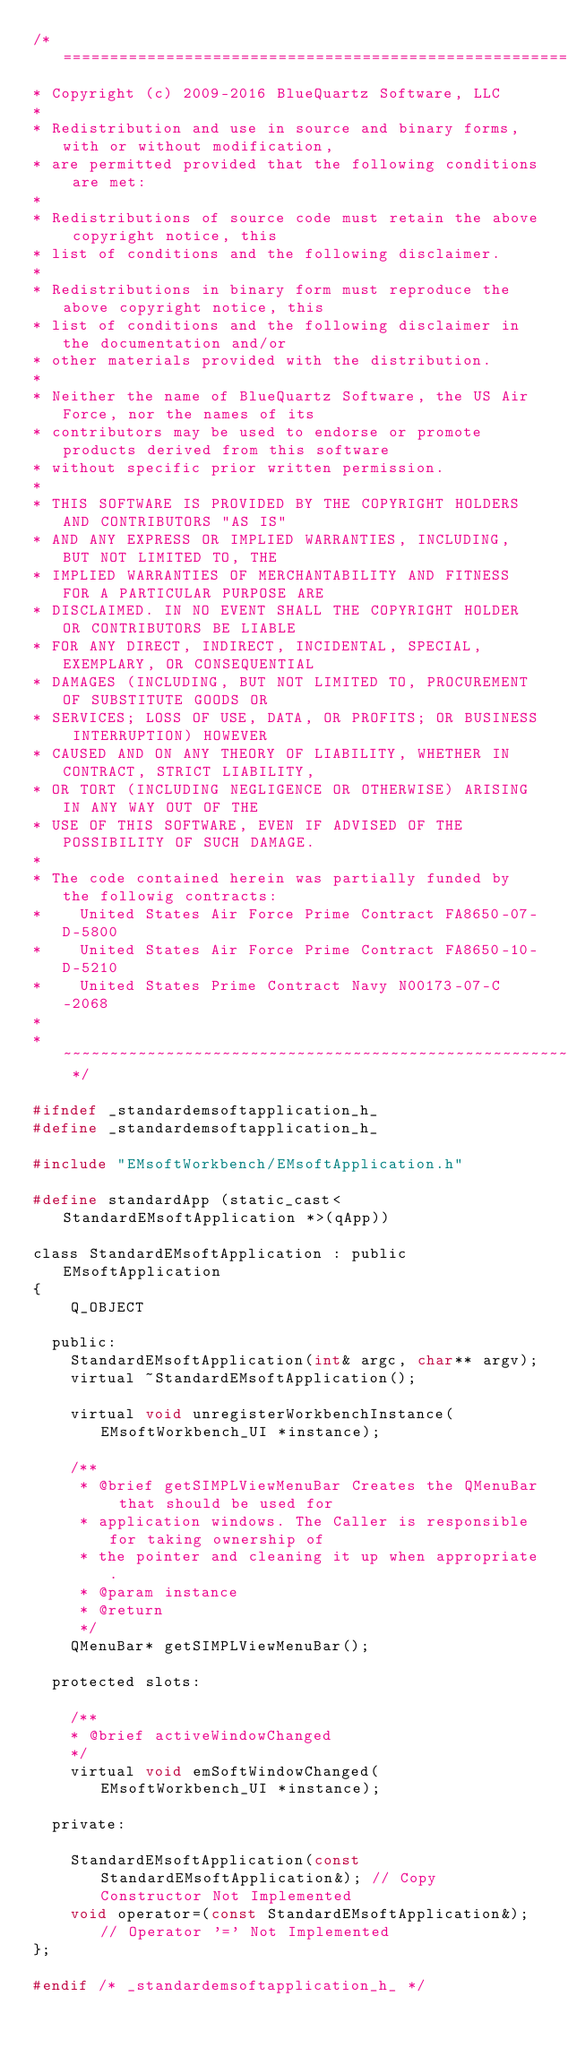Convert code to text. <code><loc_0><loc_0><loc_500><loc_500><_C_>/* ============================================================================
* Copyright (c) 2009-2016 BlueQuartz Software, LLC
*
* Redistribution and use in source and binary forms, with or without modification,
* are permitted provided that the following conditions are met:
*
* Redistributions of source code must retain the above copyright notice, this
* list of conditions and the following disclaimer.
*
* Redistributions in binary form must reproduce the above copyright notice, this
* list of conditions and the following disclaimer in the documentation and/or
* other materials provided with the distribution.
*
* Neither the name of BlueQuartz Software, the US Air Force, nor the names of its
* contributors may be used to endorse or promote products derived from this software
* without specific prior written permission.
*
* THIS SOFTWARE IS PROVIDED BY THE COPYRIGHT HOLDERS AND CONTRIBUTORS "AS IS"
* AND ANY EXPRESS OR IMPLIED WARRANTIES, INCLUDING, BUT NOT LIMITED TO, THE
* IMPLIED WARRANTIES OF MERCHANTABILITY AND FITNESS FOR A PARTICULAR PURPOSE ARE
* DISCLAIMED. IN NO EVENT SHALL THE COPYRIGHT HOLDER OR CONTRIBUTORS BE LIABLE
* FOR ANY DIRECT, INDIRECT, INCIDENTAL, SPECIAL, EXEMPLARY, OR CONSEQUENTIAL
* DAMAGES (INCLUDING, BUT NOT LIMITED TO, PROCUREMENT OF SUBSTITUTE GOODS OR
* SERVICES; LOSS OF USE, DATA, OR PROFITS; OR BUSINESS INTERRUPTION) HOWEVER
* CAUSED AND ON ANY THEORY OF LIABILITY, WHETHER IN CONTRACT, STRICT LIABILITY,
* OR TORT (INCLUDING NEGLIGENCE OR OTHERWISE) ARISING IN ANY WAY OUT OF THE
* USE OF THIS SOFTWARE, EVEN IF ADVISED OF THE POSSIBILITY OF SUCH DAMAGE.
*
* The code contained herein was partially funded by the followig contracts:
*    United States Air Force Prime Contract FA8650-07-D-5800
*    United States Air Force Prime Contract FA8650-10-D-5210
*    United States Prime Contract Navy N00173-07-C-2068
*
* ~~~~~~~~~~~~~~~~~~~~~~~~~~~~~~~~~~~~~~~~~~~~~~~~~~~~~~~~~~~~~~~~~~~~~~~~~~ */

#ifndef _standardemsoftapplication_h_
#define _standardemsoftapplication_h_

#include "EMsoftWorkbench/EMsoftApplication.h"

#define standardApp (static_cast<StandardEMsoftApplication *>(qApp))

class StandardEMsoftApplication : public EMsoftApplication
{
    Q_OBJECT

  public:
    StandardEMsoftApplication(int& argc, char** argv);
    virtual ~StandardEMsoftApplication();

    virtual void unregisterWorkbenchInstance(EMsoftWorkbench_UI *instance);

    /**
     * @brief getSIMPLViewMenuBar Creates the QMenuBar that should be used for
     * application windows. The Caller is responsible for taking ownership of
     * the pointer and cleaning it up when appropriate.
     * @param instance
     * @return
     */
    QMenuBar* getSIMPLViewMenuBar();

  protected slots:

    /**
    * @brief activeWindowChanged
    */
    virtual void emSoftWindowChanged(EMsoftWorkbench_UI *instance);

  private:

    StandardEMsoftApplication(const StandardEMsoftApplication&); // Copy Constructor Not Implemented
    void operator=(const StandardEMsoftApplication&); // Operator '=' Not Implemented
};

#endif /* _standardemsoftapplication_h_ */

</code> 